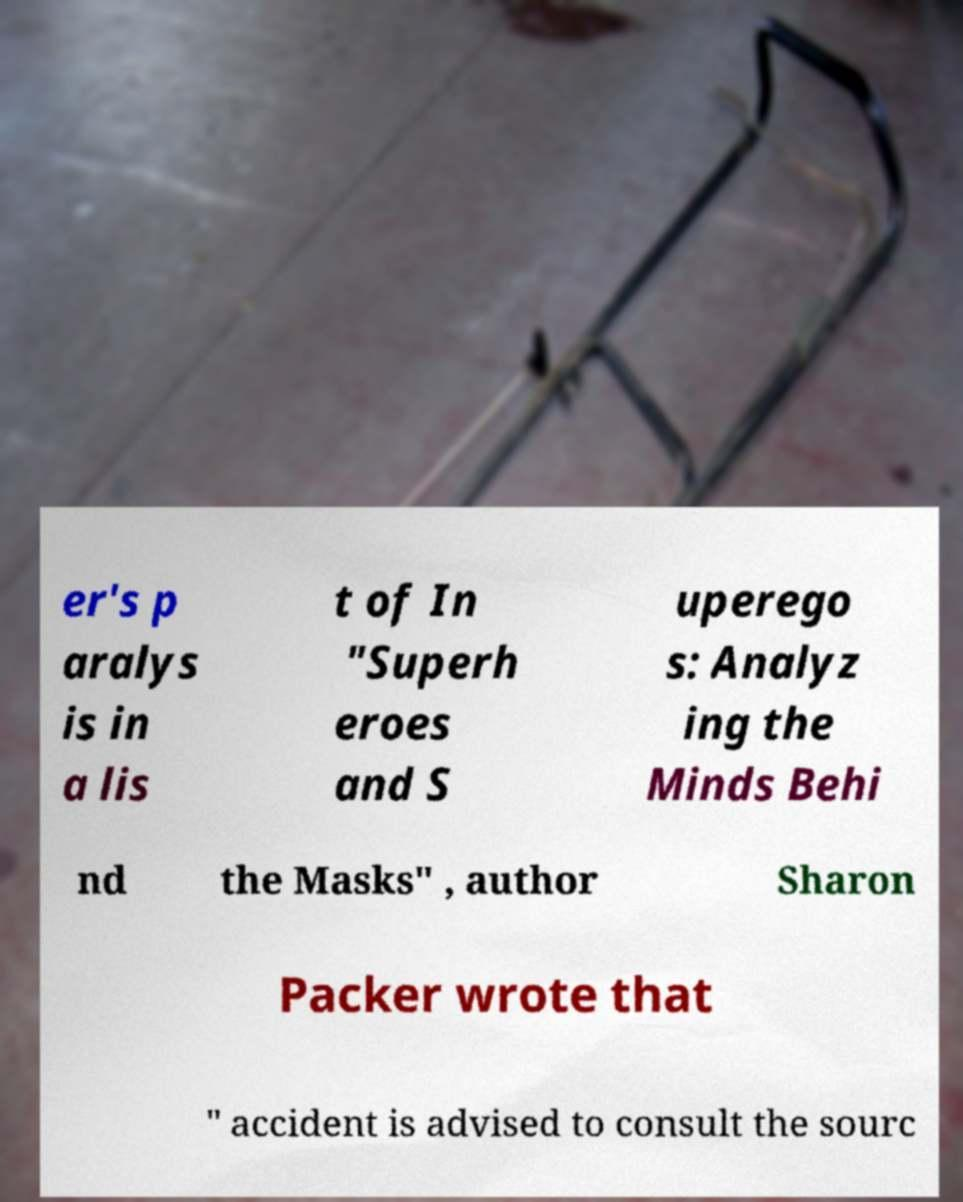Could you extract and type out the text from this image? er's p aralys is in a lis t of In "Superh eroes and S uperego s: Analyz ing the Minds Behi nd the Masks" , author Sharon Packer wrote that " accident is advised to consult the sourc 